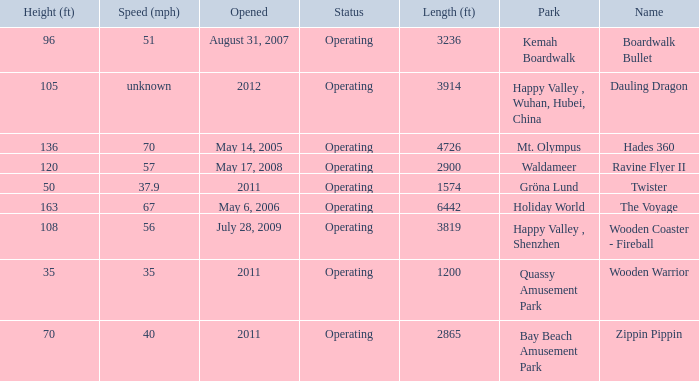Help me parse the entirety of this table. {'header': ['Height (ft)', 'Speed (mph)', 'Opened', 'Status', 'Length (ft)', 'Park', 'Name'], 'rows': [['96', '51', 'August 31, 2007', 'Operating', '3236', 'Kemah Boardwalk', 'Boardwalk Bullet'], ['105', 'unknown', '2012', 'Operating', '3914', 'Happy Valley , Wuhan, Hubei, China', 'Dauling Dragon'], ['136', '70', 'May 14, 2005', 'Operating', '4726', 'Mt. Olympus', 'Hades 360'], ['120', '57', 'May 17, 2008', 'Operating', '2900', 'Waldameer', 'Ravine Flyer II'], ['50', '37.9', '2011', 'Operating', '1574', 'Gröna Lund', 'Twister'], ['163', '67', 'May 6, 2006', 'Operating', '6442', 'Holiday World', 'The Voyage'], ['108', '56', 'July 28, 2009', 'Operating', '3819', 'Happy Valley , Shenzhen', 'Wooden Coaster - Fireball'], ['35', '35', '2011', 'Operating', '1200', 'Quassy Amusement Park', 'Wooden Warrior'], ['70', '40', '2011', 'Operating', '2865', 'Bay Beach Amusement Park', 'Zippin Pippin']]} What park is Boardwalk Bullet located in? Kemah Boardwalk. 